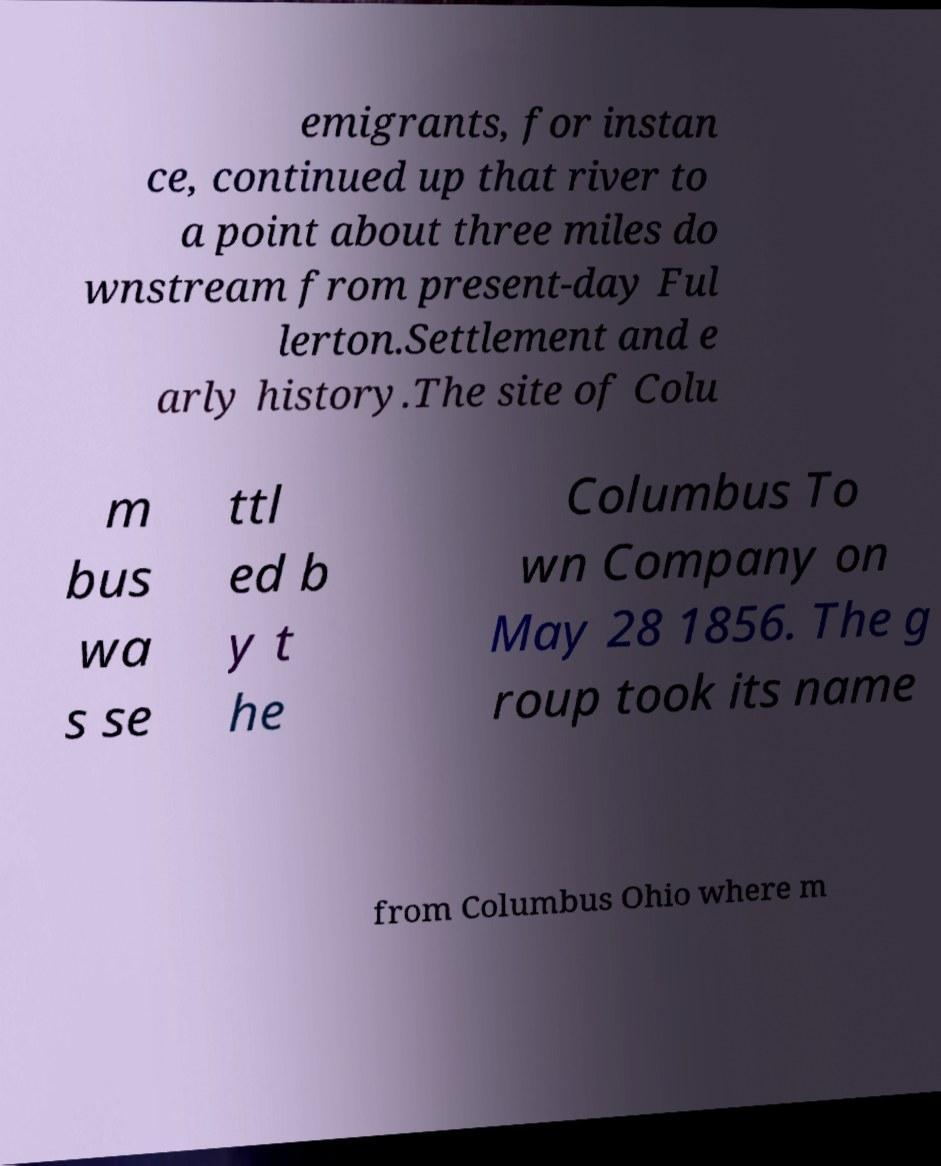Could you assist in decoding the text presented in this image and type it out clearly? emigrants, for instan ce, continued up that river to a point about three miles do wnstream from present-day Ful lerton.Settlement and e arly history.The site of Colu m bus wa s se ttl ed b y t he Columbus To wn Company on May 28 1856. The g roup took its name from Columbus Ohio where m 